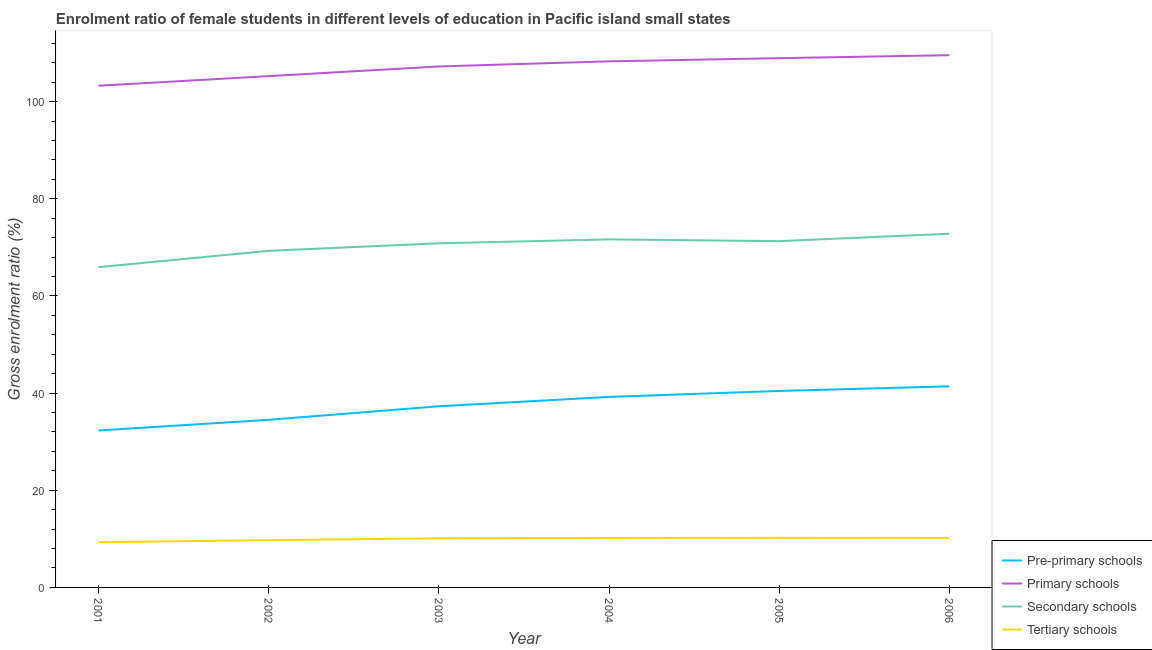How many different coloured lines are there?
Give a very brief answer. 4. Does the line corresponding to gross enrolment ratio(male) in pre-primary schools intersect with the line corresponding to gross enrolment ratio(male) in primary schools?
Provide a succinct answer. No. What is the gross enrolment ratio(male) in pre-primary schools in 2004?
Provide a short and direct response. 39.22. Across all years, what is the maximum gross enrolment ratio(male) in tertiary schools?
Offer a very short reply. 10.21. Across all years, what is the minimum gross enrolment ratio(male) in primary schools?
Provide a succinct answer. 103.28. In which year was the gross enrolment ratio(male) in tertiary schools maximum?
Make the answer very short. 2005. In which year was the gross enrolment ratio(male) in primary schools minimum?
Make the answer very short. 2001. What is the total gross enrolment ratio(male) in pre-primary schools in the graph?
Your answer should be very brief. 225.15. What is the difference between the gross enrolment ratio(male) in primary schools in 2005 and that in 2006?
Give a very brief answer. -0.62. What is the difference between the gross enrolment ratio(male) in tertiary schools in 2002 and the gross enrolment ratio(male) in pre-primary schools in 2004?
Your response must be concise. -29.48. What is the average gross enrolment ratio(male) in pre-primary schools per year?
Your response must be concise. 37.53. In the year 2002, what is the difference between the gross enrolment ratio(male) in secondary schools and gross enrolment ratio(male) in primary schools?
Ensure brevity in your answer.  -35.96. In how many years, is the gross enrolment ratio(male) in tertiary schools greater than 80 %?
Make the answer very short. 0. What is the ratio of the gross enrolment ratio(male) in secondary schools in 2002 to that in 2004?
Give a very brief answer. 0.97. What is the difference between the highest and the second highest gross enrolment ratio(male) in secondary schools?
Provide a short and direct response. 1.16. What is the difference between the highest and the lowest gross enrolment ratio(male) in pre-primary schools?
Your answer should be very brief. 9.09. Is it the case that in every year, the sum of the gross enrolment ratio(male) in tertiary schools and gross enrolment ratio(male) in secondary schools is greater than the sum of gross enrolment ratio(male) in pre-primary schools and gross enrolment ratio(male) in primary schools?
Provide a short and direct response. No. Is it the case that in every year, the sum of the gross enrolment ratio(male) in pre-primary schools and gross enrolment ratio(male) in primary schools is greater than the gross enrolment ratio(male) in secondary schools?
Give a very brief answer. Yes. Does the gross enrolment ratio(male) in secondary schools monotonically increase over the years?
Make the answer very short. No. Is the gross enrolment ratio(male) in secondary schools strictly greater than the gross enrolment ratio(male) in tertiary schools over the years?
Make the answer very short. Yes. How many years are there in the graph?
Your answer should be compact. 6. What is the difference between two consecutive major ticks on the Y-axis?
Offer a terse response. 20. Does the graph contain any zero values?
Provide a succinct answer. No. Where does the legend appear in the graph?
Ensure brevity in your answer.  Bottom right. How many legend labels are there?
Make the answer very short. 4. How are the legend labels stacked?
Give a very brief answer. Vertical. What is the title of the graph?
Offer a terse response. Enrolment ratio of female students in different levels of education in Pacific island small states. Does "Sweden" appear as one of the legend labels in the graph?
Provide a short and direct response. No. What is the Gross enrolment ratio (%) in Pre-primary schools in 2001?
Your response must be concise. 32.31. What is the Gross enrolment ratio (%) of Primary schools in 2001?
Provide a succinct answer. 103.28. What is the Gross enrolment ratio (%) in Secondary schools in 2001?
Your response must be concise. 65.93. What is the Gross enrolment ratio (%) of Tertiary schools in 2001?
Ensure brevity in your answer.  9.31. What is the Gross enrolment ratio (%) of Pre-primary schools in 2002?
Your response must be concise. 34.5. What is the Gross enrolment ratio (%) in Primary schools in 2002?
Offer a very short reply. 105.25. What is the Gross enrolment ratio (%) of Secondary schools in 2002?
Make the answer very short. 69.29. What is the Gross enrolment ratio (%) in Tertiary schools in 2002?
Keep it short and to the point. 9.74. What is the Gross enrolment ratio (%) of Pre-primary schools in 2003?
Provide a short and direct response. 37.29. What is the Gross enrolment ratio (%) in Primary schools in 2003?
Make the answer very short. 107.25. What is the Gross enrolment ratio (%) of Secondary schools in 2003?
Your answer should be very brief. 70.84. What is the Gross enrolment ratio (%) of Tertiary schools in 2003?
Provide a short and direct response. 10.11. What is the Gross enrolment ratio (%) in Pre-primary schools in 2004?
Provide a succinct answer. 39.22. What is the Gross enrolment ratio (%) of Primary schools in 2004?
Your answer should be very brief. 108.3. What is the Gross enrolment ratio (%) in Secondary schools in 2004?
Offer a terse response. 71.64. What is the Gross enrolment ratio (%) of Tertiary schools in 2004?
Offer a terse response. 10.17. What is the Gross enrolment ratio (%) of Pre-primary schools in 2005?
Offer a very short reply. 40.45. What is the Gross enrolment ratio (%) in Primary schools in 2005?
Offer a very short reply. 108.95. What is the Gross enrolment ratio (%) in Secondary schools in 2005?
Keep it short and to the point. 71.28. What is the Gross enrolment ratio (%) of Tertiary schools in 2005?
Offer a terse response. 10.21. What is the Gross enrolment ratio (%) of Pre-primary schools in 2006?
Offer a very short reply. 41.39. What is the Gross enrolment ratio (%) in Primary schools in 2006?
Give a very brief answer. 109.57. What is the Gross enrolment ratio (%) of Secondary schools in 2006?
Provide a succinct answer. 72.81. What is the Gross enrolment ratio (%) of Tertiary schools in 2006?
Keep it short and to the point. 10.19. Across all years, what is the maximum Gross enrolment ratio (%) of Pre-primary schools?
Provide a short and direct response. 41.39. Across all years, what is the maximum Gross enrolment ratio (%) in Primary schools?
Provide a short and direct response. 109.57. Across all years, what is the maximum Gross enrolment ratio (%) in Secondary schools?
Make the answer very short. 72.81. Across all years, what is the maximum Gross enrolment ratio (%) of Tertiary schools?
Keep it short and to the point. 10.21. Across all years, what is the minimum Gross enrolment ratio (%) of Pre-primary schools?
Make the answer very short. 32.31. Across all years, what is the minimum Gross enrolment ratio (%) in Primary schools?
Give a very brief answer. 103.28. Across all years, what is the minimum Gross enrolment ratio (%) of Secondary schools?
Make the answer very short. 65.93. Across all years, what is the minimum Gross enrolment ratio (%) in Tertiary schools?
Provide a short and direct response. 9.31. What is the total Gross enrolment ratio (%) of Pre-primary schools in the graph?
Your answer should be compact. 225.15. What is the total Gross enrolment ratio (%) of Primary schools in the graph?
Your answer should be very brief. 642.59. What is the total Gross enrolment ratio (%) in Secondary schools in the graph?
Give a very brief answer. 421.79. What is the total Gross enrolment ratio (%) in Tertiary schools in the graph?
Provide a succinct answer. 59.73. What is the difference between the Gross enrolment ratio (%) in Pre-primary schools in 2001 and that in 2002?
Provide a short and direct response. -2.19. What is the difference between the Gross enrolment ratio (%) of Primary schools in 2001 and that in 2002?
Your answer should be very brief. -1.97. What is the difference between the Gross enrolment ratio (%) of Secondary schools in 2001 and that in 2002?
Give a very brief answer. -3.36. What is the difference between the Gross enrolment ratio (%) in Tertiary schools in 2001 and that in 2002?
Offer a terse response. -0.43. What is the difference between the Gross enrolment ratio (%) in Pre-primary schools in 2001 and that in 2003?
Offer a very short reply. -4.98. What is the difference between the Gross enrolment ratio (%) of Primary schools in 2001 and that in 2003?
Make the answer very short. -3.97. What is the difference between the Gross enrolment ratio (%) of Secondary schools in 2001 and that in 2003?
Offer a terse response. -4.92. What is the difference between the Gross enrolment ratio (%) in Tertiary schools in 2001 and that in 2003?
Your answer should be very brief. -0.8. What is the difference between the Gross enrolment ratio (%) of Pre-primary schools in 2001 and that in 2004?
Keep it short and to the point. -6.91. What is the difference between the Gross enrolment ratio (%) of Primary schools in 2001 and that in 2004?
Ensure brevity in your answer.  -5.02. What is the difference between the Gross enrolment ratio (%) of Secondary schools in 2001 and that in 2004?
Your answer should be very brief. -5.72. What is the difference between the Gross enrolment ratio (%) in Tertiary schools in 2001 and that in 2004?
Give a very brief answer. -0.86. What is the difference between the Gross enrolment ratio (%) in Pre-primary schools in 2001 and that in 2005?
Offer a very short reply. -8.14. What is the difference between the Gross enrolment ratio (%) in Primary schools in 2001 and that in 2005?
Provide a short and direct response. -5.67. What is the difference between the Gross enrolment ratio (%) of Secondary schools in 2001 and that in 2005?
Provide a short and direct response. -5.36. What is the difference between the Gross enrolment ratio (%) of Tertiary schools in 2001 and that in 2005?
Your response must be concise. -0.9. What is the difference between the Gross enrolment ratio (%) in Pre-primary schools in 2001 and that in 2006?
Keep it short and to the point. -9.09. What is the difference between the Gross enrolment ratio (%) of Primary schools in 2001 and that in 2006?
Your answer should be compact. -6.29. What is the difference between the Gross enrolment ratio (%) in Secondary schools in 2001 and that in 2006?
Offer a very short reply. -6.88. What is the difference between the Gross enrolment ratio (%) in Tertiary schools in 2001 and that in 2006?
Your response must be concise. -0.88. What is the difference between the Gross enrolment ratio (%) of Pre-primary schools in 2002 and that in 2003?
Provide a succinct answer. -2.79. What is the difference between the Gross enrolment ratio (%) in Primary schools in 2002 and that in 2003?
Offer a terse response. -2. What is the difference between the Gross enrolment ratio (%) in Secondary schools in 2002 and that in 2003?
Provide a short and direct response. -1.56. What is the difference between the Gross enrolment ratio (%) of Tertiary schools in 2002 and that in 2003?
Offer a terse response. -0.37. What is the difference between the Gross enrolment ratio (%) of Pre-primary schools in 2002 and that in 2004?
Your response must be concise. -4.71. What is the difference between the Gross enrolment ratio (%) of Primary schools in 2002 and that in 2004?
Offer a terse response. -3.05. What is the difference between the Gross enrolment ratio (%) of Secondary schools in 2002 and that in 2004?
Give a very brief answer. -2.36. What is the difference between the Gross enrolment ratio (%) of Tertiary schools in 2002 and that in 2004?
Your answer should be compact. -0.44. What is the difference between the Gross enrolment ratio (%) of Pre-primary schools in 2002 and that in 2005?
Provide a succinct answer. -5.95. What is the difference between the Gross enrolment ratio (%) in Primary schools in 2002 and that in 2005?
Keep it short and to the point. -3.7. What is the difference between the Gross enrolment ratio (%) of Secondary schools in 2002 and that in 2005?
Provide a short and direct response. -2. What is the difference between the Gross enrolment ratio (%) in Tertiary schools in 2002 and that in 2005?
Offer a very short reply. -0.48. What is the difference between the Gross enrolment ratio (%) in Pre-primary schools in 2002 and that in 2006?
Your response must be concise. -6.89. What is the difference between the Gross enrolment ratio (%) in Primary schools in 2002 and that in 2006?
Your response must be concise. -4.32. What is the difference between the Gross enrolment ratio (%) in Secondary schools in 2002 and that in 2006?
Your response must be concise. -3.52. What is the difference between the Gross enrolment ratio (%) of Tertiary schools in 2002 and that in 2006?
Provide a short and direct response. -0.45. What is the difference between the Gross enrolment ratio (%) in Pre-primary schools in 2003 and that in 2004?
Ensure brevity in your answer.  -1.93. What is the difference between the Gross enrolment ratio (%) of Primary schools in 2003 and that in 2004?
Your answer should be compact. -1.06. What is the difference between the Gross enrolment ratio (%) in Secondary schools in 2003 and that in 2004?
Keep it short and to the point. -0.8. What is the difference between the Gross enrolment ratio (%) of Tertiary schools in 2003 and that in 2004?
Make the answer very short. -0.07. What is the difference between the Gross enrolment ratio (%) in Pre-primary schools in 2003 and that in 2005?
Offer a terse response. -3.16. What is the difference between the Gross enrolment ratio (%) in Primary schools in 2003 and that in 2005?
Make the answer very short. -1.7. What is the difference between the Gross enrolment ratio (%) of Secondary schools in 2003 and that in 2005?
Provide a succinct answer. -0.44. What is the difference between the Gross enrolment ratio (%) in Tertiary schools in 2003 and that in 2005?
Provide a short and direct response. -0.1. What is the difference between the Gross enrolment ratio (%) of Pre-primary schools in 2003 and that in 2006?
Provide a succinct answer. -4.1. What is the difference between the Gross enrolment ratio (%) of Primary schools in 2003 and that in 2006?
Make the answer very short. -2.32. What is the difference between the Gross enrolment ratio (%) of Secondary schools in 2003 and that in 2006?
Provide a short and direct response. -1.96. What is the difference between the Gross enrolment ratio (%) in Tertiary schools in 2003 and that in 2006?
Make the answer very short. -0.08. What is the difference between the Gross enrolment ratio (%) in Pre-primary schools in 2004 and that in 2005?
Make the answer very short. -1.23. What is the difference between the Gross enrolment ratio (%) in Primary schools in 2004 and that in 2005?
Make the answer very short. -0.65. What is the difference between the Gross enrolment ratio (%) of Secondary schools in 2004 and that in 2005?
Make the answer very short. 0.36. What is the difference between the Gross enrolment ratio (%) of Tertiary schools in 2004 and that in 2005?
Offer a very short reply. -0.04. What is the difference between the Gross enrolment ratio (%) in Pre-primary schools in 2004 and that in 2006?
Make the answer very short. -2.18. What is the difference between the Gross enrolment ratio (%) in Primary schools in 2004 and that in 2006?
Give a very brief answer. -1.26. What is the difference between the Gross enrolment ratio (%) of Secondary schools in 2004 and that in 2006?
Provide a succinct answer. -1.16. What is the difference between the Gross enrolment ratio (%) of Tertiary schools in 2004 and that in 2006?
Your answer should be very brief. -0.01. What is the difference between the Gross enrolment ratio (%) in Pre-primary schools in 2005 and that in 2006?
Make the answer very short. -0.95. What is the difference between the Gross enrolment ratio (%) of Primary schools in 2005 and that in 2006?
Ensure brevity in your answer.  -0.62. What is the difference between the Gross enrolment ratio (%) in Secondary schools in 2005 and that in 2006?
Provide a succinct answer. -1.52. What is the difference between the Gross enrolment ratio (%) of Tertiary schools in 2005 and that in 2006?
Make the answer very short. 0.03. What is the difference between the Gross enrolment ratio (%) in Pre-primary schools in 2001 and the Gross enrolment ratio (%) in Primary schools in 2002?
Give a very brief answer. -72.94. What is the difference between the Gross enrolment ratio (%) in Pre-primary schools in 2001 and the Gross enrolment ratio (%) in Secondary schools in 2002?
Offer a very short reply. -36.98. What is the difference between the Gross enrolment ratio (%) in Pre-primary schools in 2001 and the Gross enrolment ratio (%) in Tertiary schools in 2002?
Provide a succinct answer. 22.57. What is the difference between the Gross enrolment ratio (%) in Primary schools in 2001 and the Gross enrolment ratio (%) in Secondary schools in 2002?
Provide a succinct answer. 33.99. What is the difference between the Gross enrolment ratio (%) of Primary schools in 2001 and the Gross enrolment ratio (%) of Tertiary schools in 2002?
Offer a terse response. 93.54. What is the difference between the Gross enrolment ratio (%) in Secondary schools in 2001 and the Gross enrolment ratio (%) in Tertiary schools in 2002?
Your answer should be compact. 56.19. What is the difference between the Gross enrolment ratio (%) in Pre-primary schools in 2001 and the Gross enrolment ratio (%) in Primary schools in 2003?
Provide a short and direct response. -74.94. What is the difference between the Gross enrolment ratio (%) in Pre-primary schools in 2001 and the Gross enrolment ratio (%) in Secondary schools in 2003?
Offer a terse response. -38.54. What is the difference between the Gross enrolment ratio (%) in Pre-primary schools in 2001 and the Gross enrolment ratio (%) in Tertiary schools in 2003?
Offer a very short reply. 22.2. What is the difference between the Gross enrolment ratio (%) in Primary schools in 2001 and the Gross enrolment ratio (%) in Secondary schools in 2003?
Provide a short and direct response. 32.44. What is the difference between the Gross enrolment ratio (%) in Primary schools in 2001 and the Gross enrolment ratio (%) in Tertiary schools in 2003?
Keep it short and to the point. 93.17. What is the difference between the Gross enrolment ratio (%) in Secondary schools in 2001 and the Gross enrolment ratio (%) in Tertiary schools in 2003?
Your answer should be very brief. 55.82. What is the difference between the Gross enrolment ratio (%) in Pre-primary schools in 2001 and the Gross enrolment ratio (%) in Primary schools in 2004?
Ensure brevity in your answer.  -75.99. What is the difference between the Gross enrolment ratio (%) of Pre-primary schools in 2001 and the Gross enrolment ratio (%) of Secondary schools in 2004?
Give a very brief answer. -39.34. What is the difference between the Gross enrolment ratio (%) of Pre-primary schools in 2001 and the Gross enrolment ratio (%) of Tertiary schools in 2004?
Your answer should be very brief. 22.13. What is the difference between the Gross enrolment ratio (%) of Primary schools in 2001 and the Gross enrolment ratio (%) of Secondary schools in 2004?
Give a very brief answer. 31.64. What is the difference between the Gross enrolment ratio (%) of Primary schools in 2001 and the Gross enrolment ratio (%) of Tertiary schools in 2004?
Your response must be concise. 93.11. What is the difference between the Gross enrolment ratio (%) of Secondary schools in 2001 and the Gross enrolment ratio (%) of Tertiary schools in 2004?
Offer a very short reply. 55.75. What is the difference between the Gross enrolment ratio (%) of Pre-primary schools in 2001 and the Gross enrolment ratio (%) of Primary schools in 2005?
Offer a very short reply. -76.64. What is the difference between the Gross enrolment ratio (%) of Pre-primary schools in 2001 and the Gross enrolment ratio (%) of Secondary schools in 2005?
Provide a succinct answer. -38.98. What is the difference between the Gross enrolment ratio (%) in Pre-primary schools in 2001 and the Gross enrolment ratio (%) in Tertiary schools in 2005?
Offer a very short reply. 22.09. What is the difference between the Gross enrolment ratio (%) in Primary schools in 2001 and the Gross enrolment ratio (%) in Secondary schools in 2005?
Make the answer very short. 32. What is the difference between the Gross enrolment ratio (%) of Primary schools in 2001 and the Gross enrolment ratio (%) of Tertiary schools in 2005?
Offer a very short reply. 93.07. What is the difference between the Gross enrolment ratio (%) in Secondary schools in 2001 and the Gross enrolment ratio (%) in Tertiary schools in 2005?
Your answer should be very brief. 55.71. What is the difference between the Gross enrolment ratio (%) in Pre-primary schools in 2001 and the Gross enrolment ratio (%) in Primary schools in 2006?
Provide a succinct answer. -77.26. What is the difference between the Gross enrolment ratio (%) in Pre-primary schools in 2001 and the Gross enrolment ratio (%) in Secondary schools in 2006?
Your answer should be compact. -40.5. What is the difference between the Gross enrolment ratio (%) of Pre-primary schools in 2001 and the Gross enrolment ratio (%) of Tertiary schools in 2006?
Ensure brevity in your answer.  22.12. What is the difference between the Gross enrolment ratio (%) of Primary schools in 2001 and the Gross enrolment ratio (%) of Secondary schools in 2006?
Your answer should be compact. 30.47. What is the difference between the Gross enrolment ratio (%) of Primary schools in 2001 and the Gross enrolment ratio (%) of Tertiary schools in 2006?
Keep it short and to the point. 93.09. What is the difference between the Gross enrolment ratio (%) of Secondary schools in 2001 and the Gross enrolment ratio (%) of Tertiary schools in 2006?
Your response must be concise. 55.74. What is the difference between the Gross enrolment ratio (%) in Pre-primary schools in 2002 and the Gross enrolment ratio (%) in Primary schools in 2003?
Make the answer very short. -72.74. What is the difference between the Gross enrolment ratio (%) in Pre-primary schools in 2002 and the Gross enrolment ratio (%) in Secondary schools in 2003?
Offer a very short reply. -36.34. What is the difference between the Gross enrolment ratio (%) of Pre-primary schools in 2002 and the Gross enrolment ratio (%) of Tertiary schools in 2003?
Offer a very short reply. 24.39. What is the difference between the Gross enrolment ratio (%) in Primary schools in 2002 and the Gross enrolment ratio (%) in Secondary schools in 2003?
Make the answer very short. 34.41. What is the difference between the Gross enrolment ratio (%) in Primary schools in 2002 and the Gross enrolment ratio (%) in Tertiary schools in 2003?
Keep it short and to the point. 95.14. What is the difference between the Gross enrolment ratio (%) of Secondary schools in 2002 and the Gross enrolment ratio (%) of Tertiary schools in 2003?
Offer a very short reply. 59.18. What is the difference between the Gross enrolment ratio (%) in Pre-primary schools in 2002 and the Gross enrolment ratio (%) in Primary schools in 2004?
Make the answer very short. -73.8. What is the difference between the Gross enrolment ratio (%) in Pre-primary schools in 2002 and the Gross enrolment ratio (%) in Secondary schools in 2004?
Your answer should be very brief. -37.14. What is the difference between the Gross enrolment ratio (%) of Pre-primary schools in 2002 and the Gross enrolment ratio (%) of Tertiary schools in 2004?
Make the answer very short. 24.33. What is the difference between the Gross enrolment ratio (%) of Primary schools in 2002 and the Gross enrolment ratio (%) of Secondary schools in 2004?
Offer a terse response. 33.61. What is the difference between the Gross enrolment ratio (%) of Primary schools in 2002 and the Gross enrolment ratio (%) of Tertiary schools in 2004?
Keep it short and to the point. 95.08. What is the difference between the Gross enrolment ratio (%) in Secondary schools in 2002 and the Gross enrolment ratio (%) in Tertiary schools in 2004?
Your answer should be compact. 59.11. What is the difference between the Gross enrolment ratio (%) of Pre-primary schools in 2002 and the Gross enrolment ratio (%) of Primary schools in 2005?
Ensure brevity in your answer.  -74.45. What is the difference between the Gross enrolment ratio (%) in Pre-primary schools in 2002 and the Gross enrolment ratio (%) in Secondary schools in 2005?
Provide a short and direct response. -36.78. What is the difference between the Gross enrolment ratio (%) in Pre-primary schools in 2002 and the Gross enrolment ratio (%) in Tertiary schools in 2005?
Keep it short and to the point. 24.29. What is the difference between the Gross enrolment ratio (%) of Primary schools in 2002 and the Gross enrolment ratio (%) of Secondary schools in 2005?
Provide a short and direct response. 33.97. What is the difference between the Gross enrolment ratio (%) of Primary schools in 2002 and the Gross enrolment ratio (%) of Tertiary schools in 2005?
Give a very brief answer. 95.04. What is the difference between the Gross enrolment ratio (%) in Secondary schools in 2002 and the Gross enrolment ratio (%) in Tertiary schools in 2005?
Ensure brevity in your answer.  59.07. What is the difference between the Gross enrolment ratio (%) of Pre-primary schools in 2002 and the Gross enrolment ratio (%) of Primary schools in 2006?
Make the answer very short. -75.06. What is the difference between the Gross enrolment ratio (%) of Pre-primary schools in 2002 and the Gross enrolment ratio (%) of Secondary schools in 2006?
Offer a terse response. -38.3. What is the difference between the Gross enrolment ratio (%) of Pre-primary schools in 2002 and the Gross enrolment ratio (%) of Tertiary schools in 2006?
Provide a short and direct response. 24.32. What is the difference between the Gross enrolment ratio (%) in Primary schools in 2002 and the Gross enrolment ratio (%) in Secondary schools in 2006?
Provide a succinct answer. 32.45. What is the difference between the Gross enrolment ratio (%) of Primary schools in 2002 and the Gross enrolment ratio (%) of Tertiary schools in 2006?
Make the answer very short. 95.06. What is the difference between the Gross enrolment ratio (%) in Secondary schools in 2002 and the Gross enrolment ratio (%) in Tertiary schools in 2006?
Give a very brief answer. 59.1. What is the difference between the Gross enrolment ratio (%) of Pre-primary schools in 2003 and the Gross enrolment ratio (%) of Primary schools in 2004?
Provide a succinct answer. -71.01. What is the difference between the Gross enrolment ratio (%) in Pre-primary schools in 2003 and the Gross enrolment ratio (%) in Secondary schools in 2004?
Provide a short and direct response. -34.35. What is the difference between the Gross enrolment ratio (%) of Pre-primary schools in 2003 and the Gross enrolment ratio (%) of Tertiary schools in 2004?
Give a very brief answer. 27.12. What is the difference between the Gross enrolment ratio (%) of Primary schools in 2003 and the Gross enrolment ratio (%) of Secondary schools in 2004?
Your answer should be compact. 35.6. What is the difference between the Gross enrolment ratio (%) of Primary schools in 2003 and the Gross enrolment ratio (%) of Tertiary schools in 2004?
Keep it short and to the point. 97.07. What is the difference between the Gross enrolment ratio (%) in Secondary schools in 2003 and the Gross enrolment ratio (%) in Tertiary schools in 2004?
Keep it short and to the point. 60.67. What is the difference between the Gross enrolment ratio (%) of Pre-primary schools in 2003 and the Gross enrolment ratio (%) of Primary schools in 2005?
Make the answer very short. -71.66. What is the difference between the Gross enrolment ratio (%) in Pre-primary schools in 2003 and the Gross enrolment ratio (%) in Secondary schools in 2005?
Your answer should be compact. -33.99. What is the difference between the Gross enrolment ratio (%) in Pre-primary schools in 2003 and the Gross enrolment ratio (%) in Tertiary schools in 2005?
Keep it short and to the point. 27.08. What is the difference between the Gross enrolment ratio (%) of Primary schools in 2003 and the Gross enrolment ratio (%) of Secondary schools in 2005?
Give a very brief answer. 35.96. What is the difference between the Gross enrolment ratio (%) of Primary schools in 2003 and the Gross enrolment ratio (%) of Tertiary schools in 2005?
Your answer should be very brief. 97.03. What is the difference between the Gross enrolment ratio (%) in Secondary schools in 2003 and the Gross enrolment ratio (%) in Tertiary schools in 2005?
Give a very brief answer. 60.63. What is the difference between the Gross enrolment ratio (%) in Pre-primary schools in 2003 and the Gross enrolment ratio (%) in Primary schools in 2006?
Provide a succinct answer. -72.28. What is the difference between the Gross enrolment ratio (%) in Pre-primary schools in 2003 and the Gross enrolment ratio (%) in Secondary schools in 2006?
Offer a very short reply. -35.52. What is the difference between the Gross enrolment ratio (%) of Pre-primary schools in 2003 and the Gross enrolment ratio (%) of Tertiary schools in 2006?
Your answer should be compact. 27.1. What is the difference between the Gross enrolment ratio (%) of Primary schools in 2003 and the Gross enrolment ratio (%) of Secondary schools in 2006?
Your answer should be compact. 34.44. What is the difference between the Gross enrolment ratio (%) of Primary schools in 2003 and the Gross enrolment ratio (%) of Tertiary schools in 2006?
Your answer should be compact. 97.06. What is the difference between the Gross enrolment ratio (%) in Secondary schools in 2003 and the Gross enrolment ratio (%) in Tertiary schools in 2006?
Your answer should be very brief. 60.66. What is the difference between the Gross enrolment ratio (%) in Pre-primary schools in 2004 and the Gross enrolment ratio (%) in Primary schools in 2005?
Keep it short and to the point. -69.73. What is the difference between the Gross enrolment ratio (%) of Pre-primary schools in 2004 and the Gross enrolment ratio (%) of Secondary schools in 2005?
Offer a very short reply. -32.07. What is the difference between the Gross enrolment ratio (%) in Pre-primary schools in 2004 and the Gross enrolment ratio (%) in Tertiary schools in 2005?
Give a very brief answer. 29. What is the difference between the Gross enrolment ratio (%) in Primary schools in 2004 and the Gross enrolment ratio (%) in Secondary schools in 2005?
Ensure brevity in your answer.  37.02. What is the difference between the Gross enrolment ratio (%) in Primary schools in 2004 and the Gross enrolment ratio (%) in Tertiary schools in 2005?
Your answer should be very brief. 98.09. What is the difference between the Gross enrolment ratio (%) in Secondary schools in 2004 and the Gross enrolment ratio (%) in Tertiary schools in 2005?
Make the answer very short. 61.43. What is the difference between the Gross enrolment ratio (%) of Pre-primary schools in 2004 and the Gross enrolment ratio (%) of Primary schools in 2006?
Keep it short and to the point. -70.35. What is the difference between the Gross enrolment ratio (%) of Pre-primary schools in 2004 and the Gross enrolment ratio (%) of Secondary schools in 2006?
Your answer should be compact. -33.59. What is the difference between the Gross enrolment ratio (%) of Pre-primary schools in 2004 and the Gross enrolment ratio (%) of Tertiary schools in 2006?
Your response must be concise. 29.03. What is the difference between the Gross enrolment ratio (%) of Primary schools in 2004 and the Gross enrolment ratio (%) of Secondary schools in 2006?
Your answer should be compact. 35.5. What is the difference between the Gross enrolment ratio (%) in Primary schools in 2004 and the Gross enrolment ratio (%) in Tertiary schools in 2006?
Provide a succinct answer. 98.11. What is the difference between the Gross enrolment ratio (%) of Secondary schools in 2004 and the Gross enrolment ratio (%) of Tertiary schools in 2006?
Make the answer very short. 61.46. What is the difference between the Gross enrolment ratio (%) of Pre-primary schools in 2005 and the Gross enrolment ratio (%) of Primary schools in 2006?
Make the answer very short. -69.12. What is the difference between the Gross enrolment ratio (%) in Pre-primary schools in 2005 and the Gross enrolment ratio (%) in Secondary schools in 2006?
Your response must be concise. -32.36. What is the difference between the Gross enrolment ratio (%) of Pre-primary schools in 2005 and the Gross enrolment ratio (%) of Tertiary schools in 2006?
Make the answer very short. 30.26. What is the difference between the Gross enrolment ratio (%) in Primary schools in 2005 and the Gross enrolment ratio (%) in Secondary schools in 2006?
Offer a terse response. 36.14. What is the difference between the Gross enrolment ratio (%) of Primary schools in 2005 and the Gross enrolment ratio (%) of Tertiary schools in 2006?
Offer a very short reply. 98.76. What is the difference between the Gross enrolment ratio (%) of Secondary schools in 2005 and the Gross enrolment ratio (%) of Tertiary schools in 2006?
Provide a short and direct response. 61.1. What is the average Gross enrolment ratio (%) in Pre-primary schools per year?
Offer a terse response. 37.53. What is the average Gross enrolment ratio (%) of Primary schools per year?
Ensure brevity in your answer.  107.1. What is the average Gross enrolment ratio (%) in Secondary schools per year?
Keep it short and to the point. 70.3. What is the average Gross enrolment ratio (%) of Tertiary schools per year?
Provide a short and direct response. 9.95. In the year 2001, what is the difference between the Gross enrolment ratio (%) of Pre-primary schools and Gross enrolment ratio (%) of Primary schools?
Provide a succinct answer. -70.97. In the year 2001, what is the difference between the Gross enrolment ratio (%) of Pre-primary schools and Gross enrolment ratio (%) of Secondary schools?
Offer a terse response. -33.62. In the year 2001, what is the difference between the Gross enrolment ratio (%) of Pre-primary schools and Gross enrolment ratio (%) of Tertiary schools?
Offer a very short reply. 23. In the year 2001, what is the difference between the Gross enrolment ratio (%) in Primary schools and Gross enrolment ratio (%) in Secondary schools?
Offer a terse response. 37.35. In the year 2001, what is the difference between the Gross enrolment ratio (%) in Primary schools and Gross enrolment ratio (%) in Tertiary schools?
Your response must be concise. 93.97. In the year 2001, what is the difference between the Gross enrolment ratio (%) in Secondary schools and Gross enrolment ratio (%) in Tertiary schools?
Offer a very short reply. 56.62. In the year 2002, what is the difference between the Gross enrolment ratio (%) in Pre-primary schools and Gross enrolment ratio (%) in Primary schools?
Make the answer very short. -70.75. In the year 2002, what is the difference between the Gross enrolment ratio (%) of Pre-primary schools and Gross enrolment ratio (%) of Secondary schools?
Make the answer very short. -34.78. In the year 2002, what is the difference between the Gross enrolment ratio (%) of Pre-primary schools and Gross enrolment ratio (%) of Tertiary schools?
Your answer should be compact. 24.77. In the year 2002, what is the difference between the Gross enrolment ratio (%) of Primary schools and Gross enrolment ratio (%) of Secondary schools?
Provide a succinct answer. 35.96. In the year 2002, what is the difference between the Gross enrolment ratio (%) of Primary schools and Gross enrolment ratio (%) of Tertiary schools?
Your answer should be very brief. 95.52. In the year 2002, what is the difference between the Gross enrolment ratio (%) in Secondary schools and Gross enrolment ratio (%) in Tertiary schools?
Provide a short and direct response. 59.55. In the year 2003, what is the difference between the Gross enrolment ratio (%) in Pre-primary schools and Gross enrolment ratio (%) in Primary schools?
Make the answer very short. -69.96. In the year 2003, what is the difference between the Gross enrolment ratio (%) in Pre-primary schools and Gross enrolment ratio (%) in Secondary schools?
Provide a succinct answer. -33.55. In the year 2003, what is the difference between the Gross enrolment ratio (%) of Pre-primary schools and Gross enrolment ratio (%) of Tertiary schools?
Offer a very short reply. 27.18. In the year 2003, what is the difference between the Gross enrolment ratio (%) of Primary schools and Gross enrolment ratio (%) of Secondary schools?
Give a very brief answer. 36.4. In the year 2003, what is the difference between the Gross enrolment ratio (%) in Primary schools and Gross enrolment ratio (%) in Tertiary schools?
Provide a short and direct response. 97.14. In the year 2003, what is the difference between the Gross enrolment ratio (%) of Secondary schools and Gross enrolment ratio (%) of Tertiary schools?
Keep it short and to the point. 60.73. In the year 2004, what is the difference between the Gross enrolment ratio (%) in Pre-primary schools and Gross enrolment ratio (%) in Primary schools?
Your response must be concise. -69.08. In the year 2004, what is the difference between the Gross enrolment ratio (%) of Pre-primary schools and Gross enrolment ratio (%) of Secondary schools?
Ensure brevity in your answer.  -32.43. In the year 2004, what is the difference between the Gross enrolment ratio (%) of Pre-primary schools and Gross enrolment ratio (%) of Tertiary schools?
Offer a very short reply. 29.04. In the year 2004, what is the difference between the Gross enrolment ratio (%) of Primary schools and Gross enrolment ratio (%) of Secondary schools?
Make the answer very short. 36.66. In the year 2004, what is the difference between the Gross enrolment ratio (%) in Primary schools and Gross enrolment ratio (%) in Tertiary schools?
Ensure brevity in your answer.  98.13. In the year 2004, what is the difference between the Gross enrolment ratio (%) of Secondary schools and Gross enrolment ratio (%) of Tertiary schools?
Provide a short and direct response. 61.47. In the year 2005, what is the difference between the Gross enrolment ratio (%) of Pre-primary schools and Gross enrolment ratio (%) of Primary schools?
Keep it short and to the point. -68.5. In the year 2005, what is the difference between the Gross enrolment ratio (%) of Pre-primary schools and Gross enrolment ratio (%) of Secondary schools?
Provide a short and direct response. -30.84. In the year 2005, what is the difference between the Gross enrolment ratio (%) of Pre-primary schools and Gross enrolment ratio (%) of Tertiary schools?
Make the answer very short. 30.23. In the year 2005, what is the difference between the Gross enrolment ratio (%) in Primary schools and Gross enrolment ratio (%) in Secondary schools?
Offer a very short reply. 37.67. In the year 2005, what is the difference between the Gross enrolment ratio (%) of Primary schools and Gross enrolment ratio (%) of Tertiary schools?
Offer a terse response. 98.74. In the year 2005, what is the difference between the Gross enrolment ratio (%) of Secondary schools and Gross enrolment ratio (%) of Tertiary schools?
Your answer should be very brief. 61.07. In the year 2006, what is the difference between the Gross enrolment ratio (%) in Pre-primary schools and Gross enrolment ratio (%) in Primary schools?
Your response must be concise. -68.17. In the year 2006, what is the difference between the Gross enrolment ratio (%) in Pre-primary schools and Gross enrolment ratio (%) in Secondary schools?
Keep it short and to the point. -31.41. In the year 2006, what is the difference between the Gross enrolment ratio (%) in Pre-primary schools and Gross enrolment ratio (%) in Tertiary schools?
Provide a short and direct response. 31.21. In the year 2006, what is the difference between the Gross enrolment ratio (%) of Primary schools and Gross enrolment ratio (%) of Secondary schools?
Offer a terse response. 36.76. In the year 2006, what is the difference between the Gross enrolment ratio (%) in Primary schools and Gross enrolment ratio (%) in Tertiary schools?
Offer a very short reply. 99.38. In the year 2006, what is the difference between the Gross enrolment ratio (%) of Secondary schools and Gross enrolment ratio (%) of Tertiary schools?
Your answer should be very brief. 62.62. What is the ratio of the Gross enrolment ratio (%) in Pre-primary schools in 2001 to that in 2002?
Keep it short and to the point. 0.94. What is the ratio of the Gross enrolment ratio (%) of Primary schools in 2001 to that in 2002?
Make the answer very short. 0.98. What is the ratio of the Gross enrolment ratio (%) in Secondary schools in 2001 to that in 2002?
Provide a short and direct response. 0.95. What is the ratio of the Gross enrolment ratio (%) of Tertiary schools in 2001 to that in 2002?
Provide a short and direct response. 0.96. What is the ratio of the Gross enrolment ratio (%) in Pre-primary schools in 2001 to that in 2003?
Keep it short and to the point. 0.87. What is the ratio of the Gross enrolment ratio (%) in Secondary schools in 2001 to that in 2003?
Your answer should be very brief. 0.93. What is the ratio of the Gross enrolment ratio (%) in Tertiary schools in 2001 to that in 2003?
Your answer should be very brief. 0.92. What is the ratio of the Gross enrolment ratio (%) in Pre-primary schools in 2001 to that in 2004?
Offer a very short reply. 0.82. What is the ratio of the Gross enrolment ratio (%) of Primary schools in 2001 to that in 2004?
Offer a very short reply. 0.95. What is the ratio of the Gross enrolment ratio (%) in Secondary schools in 2001 to that in 2004?
Ensure brevity in your answer.  0.92. What is the ratio of the Gross enrolment ratio (%) in Tertiary schools in 2001 to that in 2004?
Your answer should be compact. 0.92. What is the ratio of the Gross enrolment ratio (%) of Pre-primary schools in 2001 to that in 2005?
Your answer should be very brief. 0.8. What is the ratio of the Gross enrolment ratio (%) in Primary schools in 2001 to that in 2005?
Provide a succinct answer. 0.95. What is the ratio of the Gross enrolment ratio (%) of Secondary schools in 2001 to that in 2005?
Keep it short and to the point. 0.92. What is the ratio of the Gross enrolment ratio (%) in Tertiary schools in 2001 to that in 2005?
Your answer should be compact. 0.91. What is the ratio of the Gross enrolment ratio (%) of Pre-primary schools in 2001 to that in 2006?
Ensure brevity in your answer.  0.78. What is the ratio of the Gross enrolment ratio (%) in Primary schools in 2001 to that in 2006?
Your answer should be very brief. 0.94. What is the ratio of the Gross enrolment ratio (%) of Secondary schools in 2001 to that in 2006?
Your response must be concise. 0.91. What is the ratio of the Gross enrolment ratio (%) in Tertiary schools in 2001 to that in 2006?
Your response must be concise. 0.91. What is the ratio of the Gross enrolment ratio (%) of Pre-primary schools in 2002 to that in 2003?
Your response must be concise. 0.93. What is the ratio of the Gross enrolment ratio (%) of Primary schools in 2002 to that in 2003?
Your response must be concise. 0.98. What is the ratio of the Gross enrolment ratio (%) in Tertiary schools in 2002 to that in 2003?
Your answer should be compact. 0.96. What is the ratio of the Gross enrolment ratio (%) in Pre-primary schools in 2002 to that in 2004?
Your answer should be compact. 0.88. What is the ratio of the Gross enrolment ratio (%) of Primary schools in 2002 to that in 2004?
Give a very brief answer. 0.97. What is the ratio of the Gross enrolment ratio (%) in Secondary schools in 2002 to that in 2004?
Ensure brevity in your answer.  0.97. What is the ratio of the Gross enrolment ratio (%) of Pre-primary schools in 2002 to that in 2005?
Keep it short and to the point. 0.85. What is the ratio of the Gross enrolment ratio (%) in Primary schools in 2002 to that in 2005?
Offer a terse response. 0.97. What is the ratio of the Gross enrolment ratio (%) of Tertiary schools in 2002 to that in 2005?
Make the answer very short. 0.95. What is the ratio of the Gross enrolment ratio (%) in Pre-primary schools in 2002 to that in 2006?
Keep it short and to the point. 0.83. What is the ratio of the Gross enrolment ratio (%) of Primary schools in 2002 to that in 2006?
Keep it short and to the point. 0.96. What is the ratio of the Gross enrolment ratio (%) of Secondary schools in 2002 to that in 2006?
Make the answer very short. 0.95. What is the ratio of the Gross enrolment ratio (%) in Tertiary schools in 2002 to that in 2006?
Make the answer very short. 0.96. What is the ratio of the Gross enrolment ratio (%) of Pre-primary schools in 2003 to that in 2004?
Provide a short and direct response. 0.95. What is the ratio of the Gross enrolment ratio (%) of Primary schools in 2003 to that in 2004?
Provide a short and direct response. 0.99. What is the ratio of the Gross enrolment ratio (%) of Secondary schools in 2003 to that in 2004?
Offer a terse response. 0.99. What is the ratio of the Gross enrolment ratio (%) in Tertiary schools in 2003 to that in 2004?
Give a very brief answer. 0.99. What is the ratio of the Gross enrolment ratio (%) of Pre-primary schools in 2003 to that in 2005?
Offer a terse response. 0.92. What is the ratio of the Gross enrolment ratio (%) of Primary schools in 2003 to that in 2005?
Provide a succinct answer. 0.98. What is the ratio of the Gross enrolment ratio (%) in Secondary schools in 2003 to that in 2005?
Give a very brief answer. 0.99. What is the ratio of the Gross enrolment ratio (%) of Pre-primary schools in 2003 to that in 2006?
Ensure brevity in your answer.  0.9. What is the ratio of the Gross enrolment ratio (%) of Primary schools in 2003 to that in 2006?
Offer a terse response. 0.98. What is the ratio of the Gross enrolment ratio (%) in Secondary schools in 2003 to that in 2006?
Your answer should be compact. 0.97. What is the ratio of the Gross enrolment ratio (%) of Pre-primary schools in 2004 to that in 2005?
Ensure brevity in your answer.  0.97. What is the ratio of the Gross enrolment ratio (%) in Primary schools in 2004 to that in 2005?
Keep it short and to the point. 0.99. What is the ratio of the Gross enrolment ratio (%) in Secondary schools in 2004 to that in 2005?
Provide a succinct answer. 1. What is the ratio of the Gross enrolment ratio (%) of Tertiary schools in 2004 to that in 2005?
Give a very brief answer. 1. What is the ratio of the Gross enrolment ratio (%) of Pre-primary schools in 2004 to that in 2006?
Offer a very short reply. 0.95. What is the ratio of the Gross enrolment ratio (%) in Secondary schools in 2004 to that in 2006?
Give a very brief answer. 0.98. What is the ratio of the Gross enrolment ratio (%) of Pre-primary schools in 2005 to that in 2006?
Offer a terse response. 0.98. What is the ratio of the Gross enrolment ratio (%) of Secondary schools in 2005 to that in 2006?
Your answer should be very brief. 0.98. What is the difference between the highest and the second highest Gross enrolment ratio (%) of Pre-primary schools?
Offer a very short reply. 0.95. What is the difference between the highest and the second highest Gross enrolment ratio (%) of Primary schools?
Provide a short and direct response. 0.62. What is the difference between the highest and the second highest Gross enrolment ratio (%) of Secondary schools?
Give a very brief answer. 1.16. What is the difference between the highest and the second highest Gross enrolment ratio (%) of Tertiary schools?
Give a very brief answer. 0.03. What is the difference between the highest and the lowest Gross enrolment ratio (%) in Pre-primary schools?
Offer a very short reply. 9.09. What is the difference between the highest and the lowest Gross enrolment ratio (%) of Primary schools?
Give a very brief answer. 6.29. What is the difference between the highest and the lowest Gross enrolment ratio (%) of Secondary schools?
Your answer should be very brief. 6.88. What is the difference between the highest and the lowest Gross enrolment ratio (%) in Tertiary schools?
Your answer should be very brief. 0.9. 